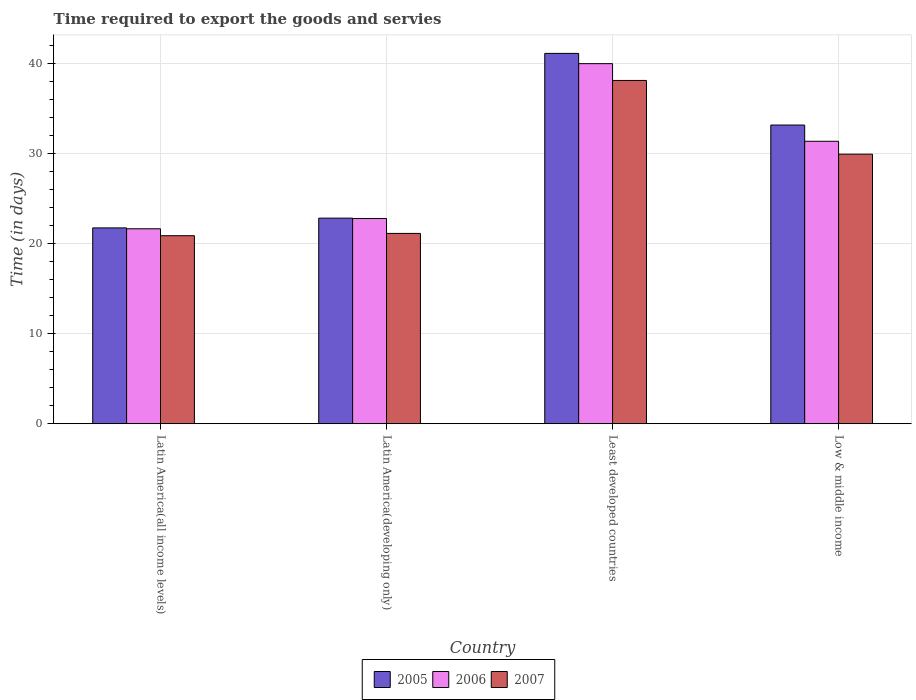How many different coloured bars are there?
Provide a succinct answer. 3. How many bars are there on the 4th tick from the left?
Offer a very short reply. 3. How many bars are there on the 1st tick from the right?
Offer a terse response. 3. What is the label of the 1st group of bars from the left?
Offer a very short reply. Latin America(all income levels). What is the number of days required to export the goods and services in 2005 in Low & middle income?
Provide a short and direct response. 33.16. Across all countries, what is the maximum number of days required to export the goods and services in 2005?
Keep it short and to the point. 41.12. Across all countries, what is the minimum number of days required to export the goods and services in 2005?
Make the answer very short. 21.74. In which country was the number of days required to export the goods and services in 2006 maximum?
Provide a short and direct response. Least developed countries. In which country was the number of days required to export the goods and services in 2005 minimum?
Give a very brief answer. Latin America(all income levels). What is the total number of days required to export the goods and services in 2007 in the graph?
Ensure brevity in your answer.  110.05. What is the difference between the number of days required to export the goods and services in 2007 in Latin America(all income levels) and that in Least developed countries?
Provide a short and direct response. -17.24. What is the difference between the number of days required to export the goods and services in 2005 in Least developed countries and the number of days required to export the goods and services in 2006 in Latin America(developing only)?
Give a very brief answer. 18.33. What is the average number of days required to export the goods and services in 2006 per country?
Your answer should be very brief. 28.94. What is the difference between the number of days required to export the goods and services of/in 2007 and number of days required to export the goods and services of/in 2005 in Latin America(all income levels)?
Give a very brief answer. -0.87. What is the ratio of the number of days required to export the goods and services in 2006 in Least developed countries to that in Low & middle income?
Keep it short and to the point. 1.27. Is the difference between the number of days required to export the goods and services in 2007 in Latin America(developing only) and Least developed countries greater than the difference between the number of days required to export the goods and services in 2005 in Latin America(developing only) and Least developed countries?
Give a very brief answer. Yes. What is the difference between the highest and the second highest number of days required to export the goods and services in 2006?
Offer a terse response. 8.58. What is the difference between the highest and the lowest number of days required to export the goods and services in 2005?
Keep it short and to the point. 19.37. What does the 1st bar from the right in Latin America(developing only) represents?
Offer a terse response. 2007. Is it the case that in every country, the sum of the number of days required to export the goods and services in 2007 and number of days required to export the goods and services in 2005 is greater than the number of days required to export the goods and services in 2006?
Ensure brevity in your answer.  Yes. Are all the bars in the graph horizontal?
Your answer should be compact. No. How many countries are there in the graph?
Provide a short and direct response. 4. Does the graph contain any zero values?
Ensure brevity in your answer.  No. How many legend labels are there?
Provide a short and direct response. 3. What is the title of the graph?
Ensure brevity in your answer.  Time required to export the goods and servies. Does "2013" appear as one of the legend labels in the graph?
Provide a succinct answer. No. What is the label or title of the X-axis?
Make the answer very short. Country. What is the label or title of the Y-axis?
Make the answer very short. Time (in days). What is the Time (in days) of 2005 in Latin America(all income levels)?
Provide a succinct answer. 21.74. What is the Time (in days) of 2006 in Latin America(all income levels)?
Ensure brevity in your answer.  21.65. What is the Time (in days) of 2007 in Latin America(all income levels)?
Your answer should be compact. 20.88. What is the Time (in days) in 2005 in Latin America(developing only)?
Provide a short and direct response. 22.83. What is the Time (in days) in 2006 in Latin America(developing only)?
Provide a short and direct response. 22.78. What is the Time (in days) of 2007 in Latin America(developing only)?
Your answer should be very brief. 21.13. What is the Time (in days) of 2005 in Least developed countries?
Make the answer very short. 41.12. What is the Time (in days) of 2006 in Least developed countries?
Keep it short and to the point. 39.98. What is the Time (in days) of 2007 in Least developed countries?
Your answer should be compact. 38.11. What is the Time (in days) of 2005 in Low & middle income?
Your answer should be compact. 33.16. What is the Time (in days) in 2006 in Low & middle income?
Your answer should be compact. 31.36. What is the Time (in days) in 2007 in Low & middle income?
Provide a short and direct response. 29.93. Across all countries, what is the maximum Time (in days) in 2005?
Keep it short and to the point. 41.12. Across all countries, what is the maximum Time (in days) in 2006?
Make the answer very short. 39.98. Across all countries, what is the maximum Time (in days) of 2007?
Keep it short and to the point. 38.11. Across all countries, what is the minimum Time (in days) of 2005?
Provide a short and direct response. 21.74. Across all countries, what is the minimum Time (in days) in 2006?
Your response must be concise. 21.65. Across all countries, what is the minimum Time (in days) of 2007?
Your answer should be very brief. 20.88. What is the total Time (in days) of 2005 in the graph?
Offer a very short reply. 118.85. What is the total Time (in days) in 2006 in the graph?
Provide a short and direct response. 115.77. What is the total Time (in days) of 2007 in the graph?
Offer a terse response. 110.05. What is the difference between the Time (in days) of 2005 in Latin America(all income levels) and that in Latin America(developing only)?
Ensure brevity in your answer.  -1.08. What is the difference between the Time (in days) in 2006 in Latin America(all income levels) and that in Latin America(developing only)?
Give a very brief answer. -1.14. What is the difference between the Time (in days) of 2007 in Latin America(all income levels) and that in Latin America(developing only)?
Your answer should be compact. -0.26. What is the difference between the Time (in days) in 2005 in Latin America(all income levels) and that in Least developed countries?
Provide a succinct answer. -19.37. What is the difference between the Time (in days) of 2006 in Latin America(all income levels) and that in Least developed countries?
Ensure brevity in your answer.  -18.33. What is the difference between the Time (in days) in 2007 in Latin America(all income levels) and that in Least developed countries?
Ensure brevity in your answer.  -17.24. What is the difference between the Time (in days) of 2005 in Latin America(all income levels) and that in Low & middle income?
Keep it short and to the point. -11.42. What is the difference between the Time (in days) of 2006 in Latin America(all income levels) and that in Low & middle income?
Offer a terse response. -9.71. What is the difference between the Time (in days) of 2007 in Latin America(all income levels) and that in Low & middle income?
Your answer should be very brief. -9.05. What is the difference between the Time (in days) of 2005 in Latin America(developing only) and that in Least developed countries?
Offer a terse response. -18.29. What is the difference between the Time (in days) in 2006 in Latin America(developing only) and that in Least developed countries?
Ensure brevity in your answer.  -17.19. What is the difference between the Time (in days) in 2007 in Latin America(developing only) and that in Least developed countries?
Provide a succinct answer. -16.98. What is the difference between the Time (in days) of 2005 in Latin America(developing only) and that in Low & middle income?
Ensure brevity in your answer.  -10.34. What is the difference between the Time (in days) in 2006 in Latin America(developing only) and that in Low & middle income?
Keep it short and to the point. -8.58. What is the difference between the Time (in days) of 2007 in Latin America(developing only) and that in Low & middle income?
Offer a terse response. -8.8. What is the difference between the Time (in days) of 2005 in Least developed countries and that in Low & middle income?
Provide a succinct answer. 7.95. What is the difference between the Time (in days) in 2006 in Least developed countries and that in Low & middle income?
Offer a terse response. 8.62. What is the difference between the Time (in days) of 2007 in Least developed countries and that in Low & middle income?
Your answer should be very brief. 8.19. What is the difference between the Time (in days) of 2005 in Latin America(all income levels) and the Time (in days) of 2006 in Latin America(developing only)?
Your answer should be compact. -1.04. What is the difference between the Time (in days) in 2005 in Latin America(all income levels) and the Time (in days) in 2007 in Latin America(developing only)?
Your response must be concise. 0.61. What is the difference between the Time (in days) of 2006 in Latin America(all income levels) and the Time (in days) of 2007 in Latin America(developing only)?
Keep it short and to the point. 0.51. What is the difference between the Time (in days) of 2005 in Latin America(all income levels) and the Time (in days) of 2006 in Least developed countries?
Your answer should be very brief. -18.24. What is the difference between the Time (in days) in 2005 in Latin America(all income levels) and the Time (in days) in 2007 in Least developed countries?
Offer a very short reply. -16.37. What is the difference between the Time (in days) in 2006 in Latin America(all income levels) and the Time (in days) in 2007 in Least developed countries?
Keep it short and to the point. -16.47. What is the difference between the Time (in days) in 2005 in Latin America(all income levels) and the Time (in days) in 2006 in Low & middle income?
Ensure brevity in your answer.  -9.62. What is the difference between the Time (in days) of 2005 in Latin America(all income levels) and the Time (in days) of 2007 in Low & middle income?
Give a very brief answer. -8.19. What is the difference between the Time (in days) of 2006 in Latin America(all income levels) and the Time (in days) of 2007 in Low & middle income?
Give a very brief answer. -8.28. What is the difference between the Time (in days) in 2005 in Latin America(developing only) and the Time (in days) in 2006 in Least developed countries?
Give a very brief answer. -17.15. What is the difference between the Time (in days) of 2005 in Latin America(developing only) and the Time (in days) of 2007 in Least developed countries?
Give a very brief answer. -15.29. What is the difference between the Time (in days) of 2006 in Latin America(developing only) and the Time (in days) of 2007 in Least developed countries?
Provide a short and direct response. -15.33. What is the difference between the Time (in days) of 2005 in Latin America(developing only) and the Time (in days) of 2006 in Low & middle income?
Keep it short and to the point. -8.53. What is the difference between the Time (in days) of 2005 in Latin America(developing only) and the Time (in days) of 2007 in Low & middle income?
Ensure brevity in your answer.  -7.1. What is the difference between the Time (in days) of 2006 in Latin America(developing only) and the Time (in days) of 2007 in Low & middle income?
Provide a succinct answer. -7.15. What is the difference between the Time (in days) in 2005 in Least developed countries and the Time (in days) in 2006 in Low & middle income?
Your answer should be very brief. 9.76. What is the difference between the Time (in days) in 2005 in Least developed countries and the Time (in days) in 2007 in Low & middle income?
Your answer should be very brief. 11.19. What is the difference between the Time (in days) in 2006 in Least developed countries and the Time (in days) in 2007 in Low & middle income?
Keep it short and to the point. 10.05. What is the average Time (in days) in 2005 per country?
Offer a terse response. 29.71. What is the average Time (in days) in 2006 per country?
Offer a terse response. 28.94. What is the average Time (in days) of 2007 per country?
Ensure brevity in your answer.  27.51. What is the difference between the Time (in days) in 2005 and Time (in days) in 2006 in Latin America(all income levels)?
Provide a succinct answer. 0.1. What is the difference between the Time (in days) in 2005 and Time (in days) in 2007 in Latin America(all income levels)?
Give a very brief answer. 0.87. What is the difference between the Time (in days) in 2006 and Time (in days) in 2007 in Latin America(all income levels)?
Your answer should be compact. 0.77. What is the difference between the Time (in days) of 2005 and Time (in days) of 2006 in Latin America(developing only)?
Your answer should be very brief. 0.04. What is the difference between the Time (in days) of 2005 and Time (in days) of 2007 in Latin America(developing only)?
Ensure brevity in your answer.  1.7. What is the difference between the Time (in days) in 2006 and Time (in days) in 2007 in Latin America(developing only)?
Your response must be concise. 1.65. What is the difference between the Time (in days) in 2005 and Time (in days) in 2006 in Least developed countries?
Your answer should be very brief. 1.14. What is the difference between the Time (in days) of 2005 and Time (in days) of 2007 in Least developed countries?
Keep it short and to the point. 3. What is the difference between the Time (in days) of 2006 and Time (in days) of 2007 in Least developed countries?
Keep it short and to the point. 1.86. What is the difference between the Time (in days) of 2005 and Time (in days) of 2006 in Low & middle income?
Your answer should be very brief. 1.8. What is the difference between the Time (in days) of 2005 and Time (in days) of 2007 in Low & middle income?
Keep it short and to the point. 3.23. What is the difference between the Time (in days) in 2006 and Time (in days) in 2007 in Low & middle income?
Your response must be concise. 1.43. What is the ratio of the Time (in days) of 2005 in Latin America(all income levels) to that in Latin America(developing only)?
Provide a short and direct response. 0.95. What is the ratio of the Time (in days) in 2006 in Latin America(all income levels) to that in Latin America(developing only)?
Offer a terse response. 0.95. What is the ratio of the Time (in days) in 2007 in Latin America(all income levels) to that in Latin America(developing only)?
Your response must be concise. 0.99. What is the ratio of the Time (in days) of 2005 in Latin America(all income levels) to that in Least developed countries?
Your response must be concise. 0.53. What is the ratio of the Time (in days) in 2006 in Latin America(all income levels) to that in Least developed countries?
Make the answer very short. 0.54. What is the ratio of the Time (in days) in 2007 in Latin America(all income levels) to that in Least developed countries?
Ensure brevity in your answer.  0.55. What is the ratio of the Time (in days) of 2005 in Latin America(all income levels) to that in Low & middle income?
Give a very brief answer. 0.66. What is the ratio of the Time (in days) in 2006 in Latin America(all income levels) to that in Low & middle income?
Keep it short and to the point. 0.69. What is the ratio of the Time (in days) of 2007 in Latin America(all income levels) to that in Low & middle income?
Keep it short and to the point. 0.7. What is the ratio of the Time (in days) of 2005 in Latin America(developing only) to that in Least developed countries?
Offer a very short reply. 0.56. What is the ratio of the Time (in days) of 2006 in Latin America(developing only) to that in Least developed countries?
Give a very brief answer. 0.57. What is the ratio of the Time (in days) in 2007 in Latin America(developing only) to that in Least developed countries?
Your response must be concise. 0.55. What is the ratio of the Time (in days) of 2005 in Latin America(developing only) to that in Low & middle income?
Offer a very short reply. 0.69. What is the ratio of the Time (in days) of 2006 in Latin America(developing only) to that in Low & middle income?
Ensure brevity in your answer.  0.73. What is the ratio of the Time (in days) of 2007 in Latin America(developing only) to that in Low & middle income?
Your answer should be very brief. 0.71. What is the ratio of the Time (in days) in 2005 in Least developed countries to that in Low & middle income?
Ensure brevity in your answer.  1.24. What is the ratio of the Time (in days) in 2006 in Least developed countries to that in Low & middle income?
Your response must be concise. 1.27. What is the ratio of the Time (in days) in 2007 in Least developed countries to that in Low & middle income?
Your response must be concise. 1.27. What is the difference between the highest and the second highest Time (in days) in 2005?
Ensure brevity in your answer.  7.95. What is the difference between the highest and the second highest Time (in days) of 2006?
Ensure brevity in your answer.  8.62. What is the difference between the highest and the second highest Time (in days) in 2007?
Offer a terse response. 8.19. What is the difference between the highest and the lowest Time (in days) in 2005?
Provide a short and direct response. 19.37. What is the difference between the highest and the lowest Time (in days) of 2006?
Make the answer very short. 18.33. What is the difference between the highest and the lowest Time (in days) in 2007?
Keep it short and to the point. 17.24. 